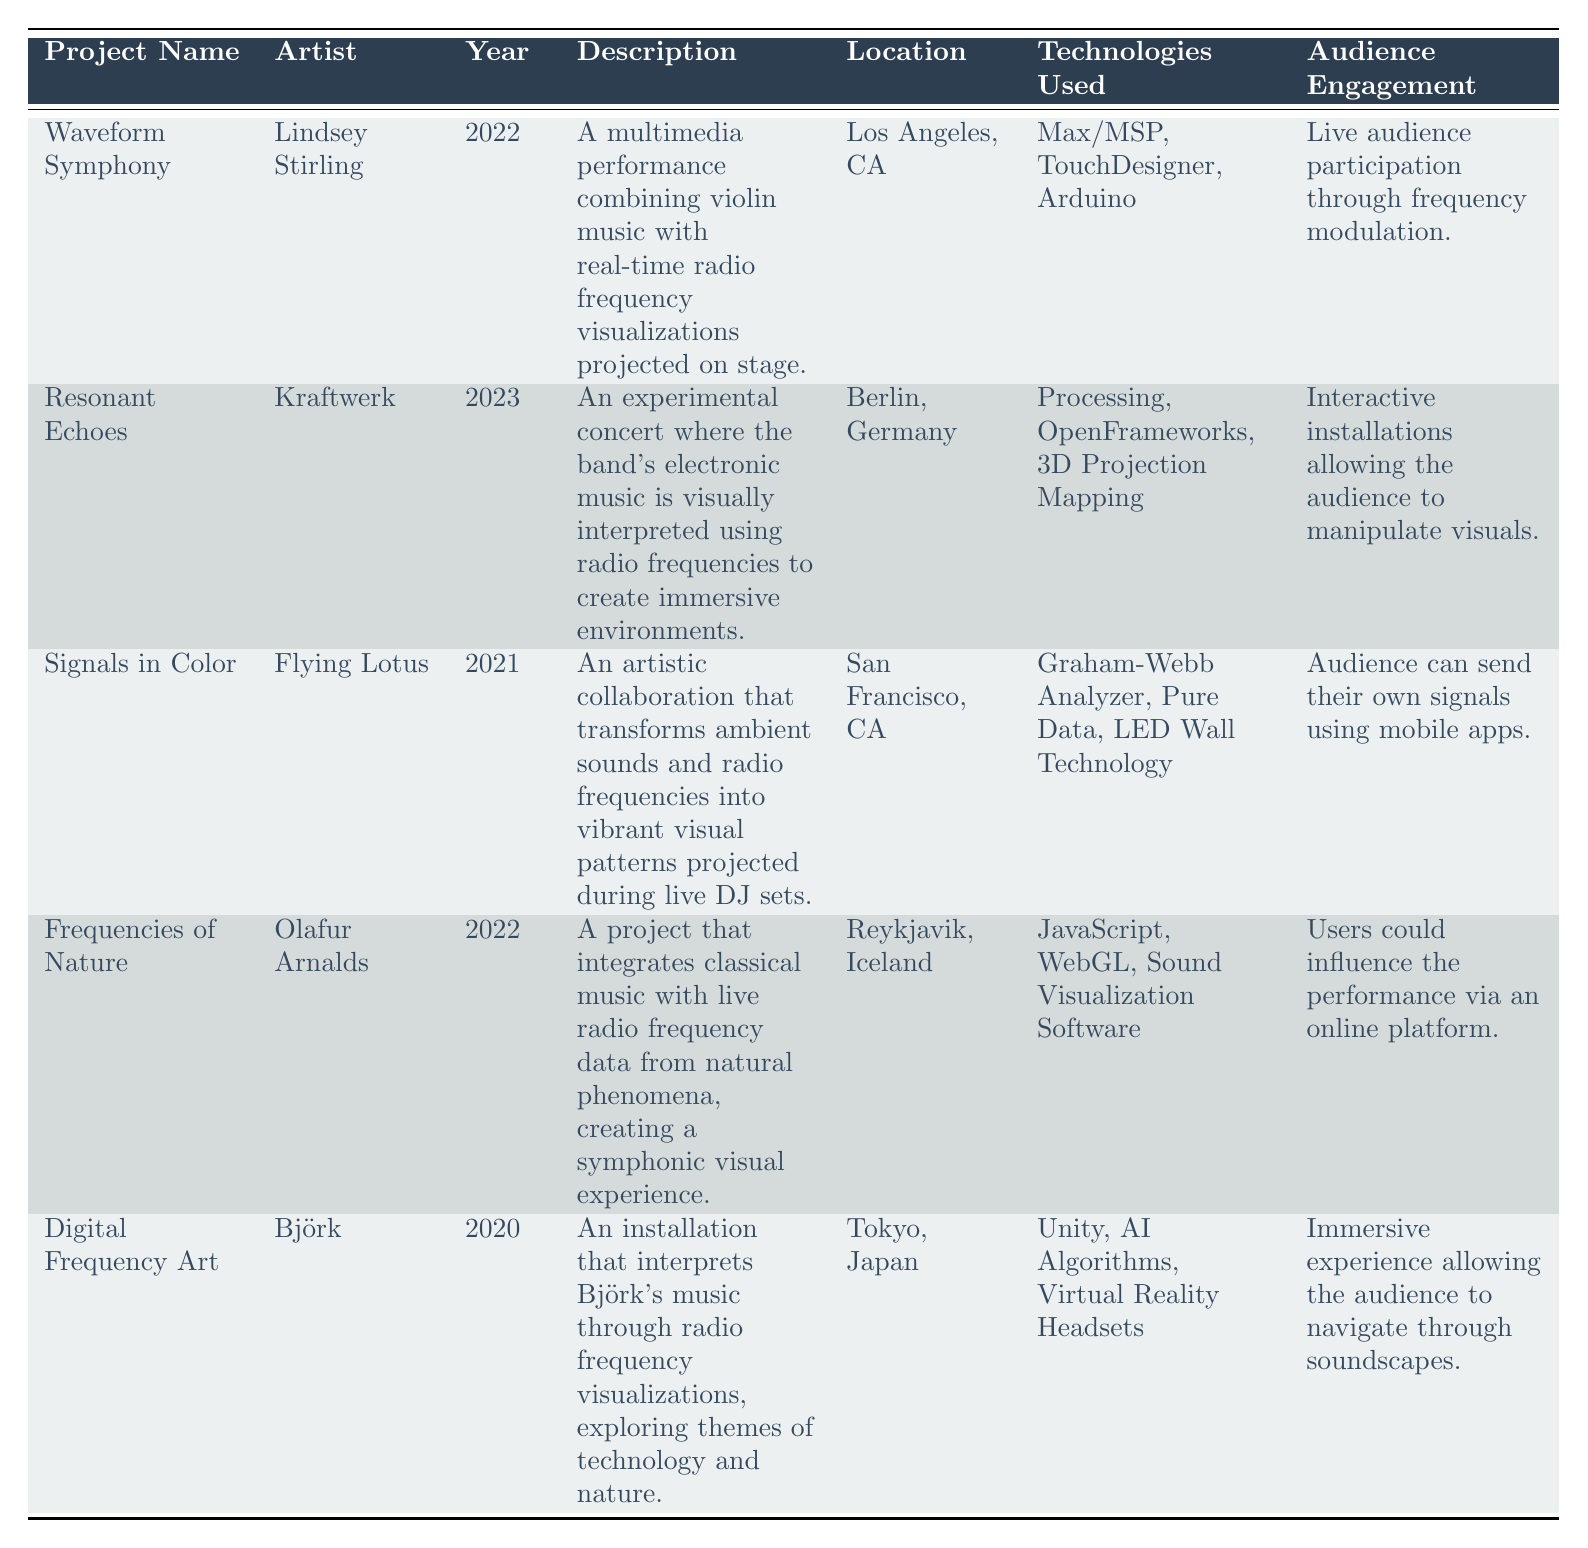What is the location of the project "Digital Frequency Art"? According to the table, the location for "Digital Frequency Art" is listed as Tokyo, Japan.
Answer: Tokyo, Japan Which artist collaborated on the project "Waveform Symphony"? The table indicates that Lindsey Stirling is the artist associated with "Waveform Symphony."
Answer: Lindsey Stirling How many projects utilized "OpenFrameworks" as a technology? From the table, only one project, "Resonant Echoes," uses "OpenFrameworks."
Answer: 1 Is "Frequencies of Nature" an example of a project that combines classical music with radio frequency data? The description for "Frequencies of Nature" confirms that it integrates classical music with live radio frequency data from natural phenomena, making the statement true.
Answer: Yes Which technology was common between both "Waveform Symphony" and "Frequencies of Nature"? By examining the technologies used in both projects, the common technology is not present; hence, there is no overlap in the technologies listed for these two specific projects.
Answer: None What year did "Signals in Color" occur compared to "Digital Frequency Art"? "Signals in Color" took place in 2021, while "Digital Frequency Art" happened in 2020. Therefore, "Signals in Color" occurred one year after "Digital Frequency Art."
Answer: 2021 If you average the years of all projects, what year do you get? The years of the projects are 2022, 2023, 2021, 2022, and 2020. Adding these years gives 2022 + 2023 + 2021 + 2022 + 2020 = 10110. Dividing by the number of projects (5) gives an average year of 2022.
Answer: 2022 Which project had the most interactive audience engagement? "Resonant Echoes" offers interactive installations that allow the audience to manipulate visuals, making it very engaging compared to the other projects listed.
Answer: Resonant Echoes What type of project was "Digital Frequency Art"? The table describes "Digital Frequency Art" as an installation interpreting Björk’s music through radio frequency visualizations, focusing on technology and nature themes.
Answer: Installation 